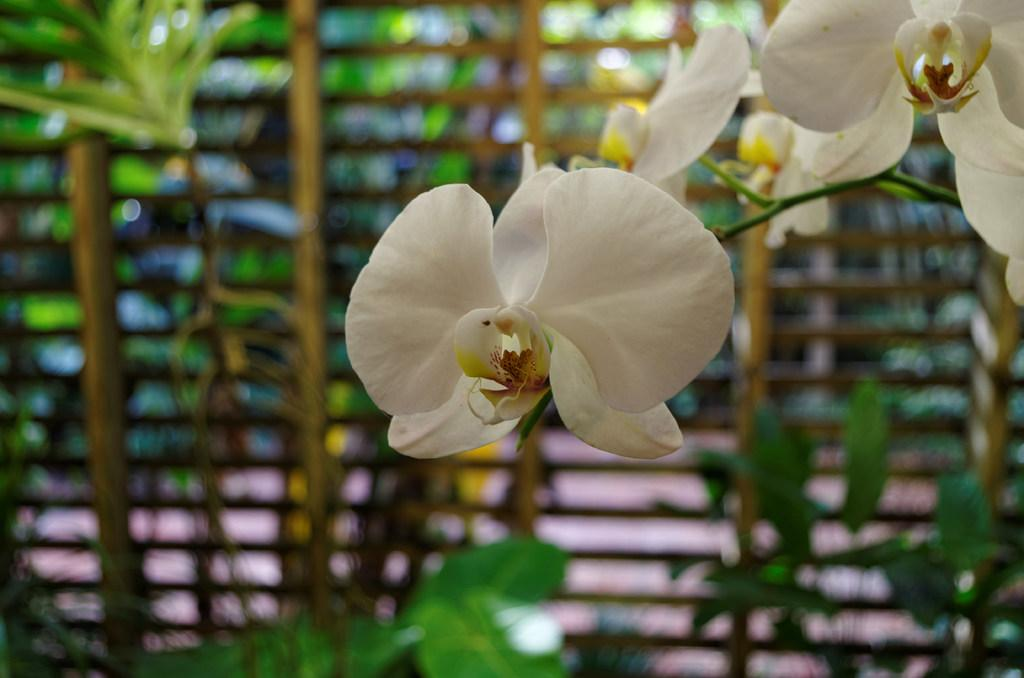What type of living organisms are present in the image? There are flowers in the image. What color are the flowers? The flowers are white in color. Can you describe the background of the image? The background of the image is blurry. What type of advice can be found in the image? There is no advice present in the image; it features white flowers with a blurry background. 